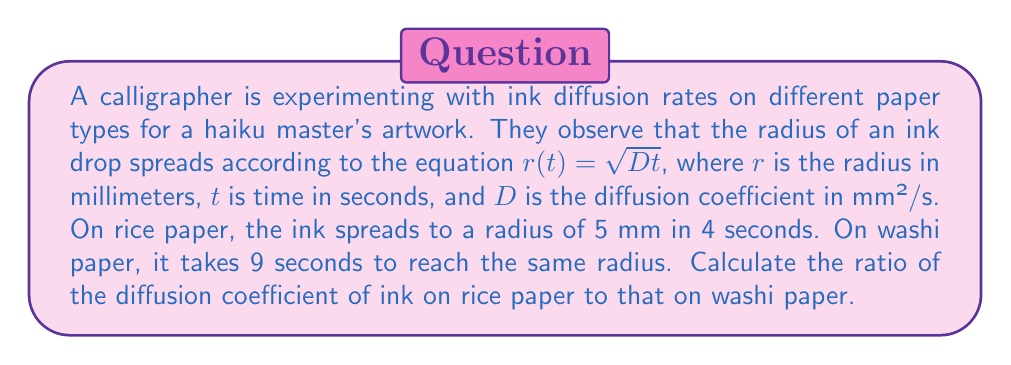Give your solution to this math problem. Let's approach this step-by-step:

1) We are given the equation $r(t) = \sqrt{Dt}$, where $D$ is the diffusion coefficient we need to find for each paper type.

2) For rice paper:
   $r = 5$ mm, $t = 4$ s
   $5 = \sqrt{D_{rice} \cdot 4}$
   $25 = 4D_{rice}$
   $D_{rice} = \frac{25}{4} = 6.25$ mm²/s

3) For washi paper:
   $r = 5$ mm, $t = 9$ s
   $5 = \sqrt{D_{washi} \cdot 9}$
   $25 = 9D_{washi}$
   $D_{washi} = \frac{25}{9} = 2.78$ mm²/s (rounded to 2 decimal places)

4) The ratio of diffusion coefficients is:
   $\frac{D_{rice}}{D_{washi}} = \frac{6.25}{2.78} = 2.25$

Therefore, the diffusion coefficient of ink on rice paper is 2.25 times that on washi paper.
Answer: 2.25 